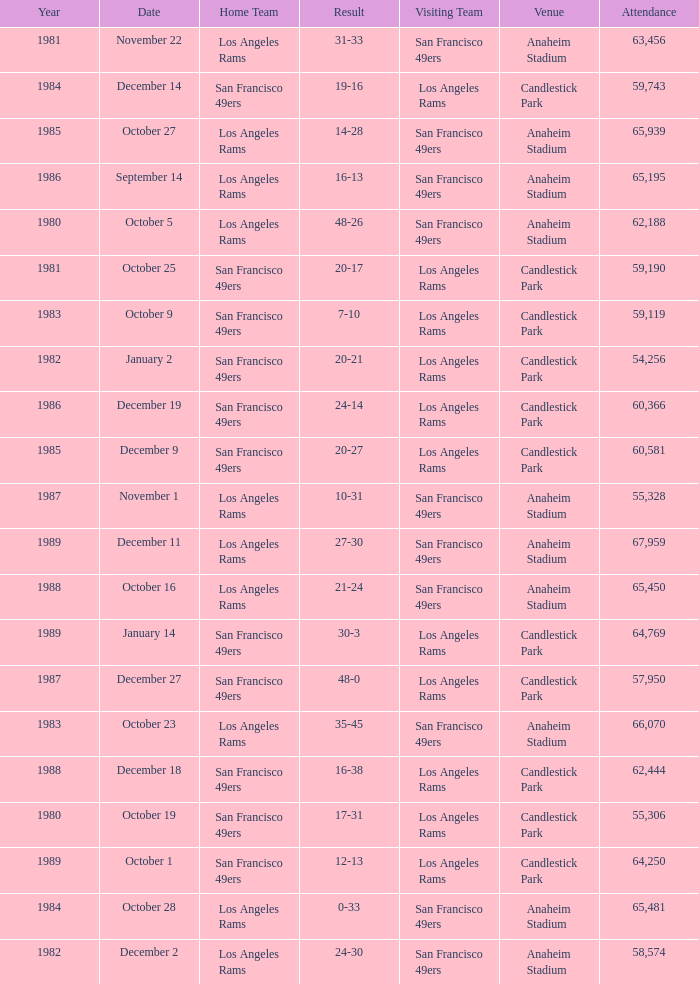What's the total attendance at anaheim stadium after 1983 when the result is 14-28? 1.0. 